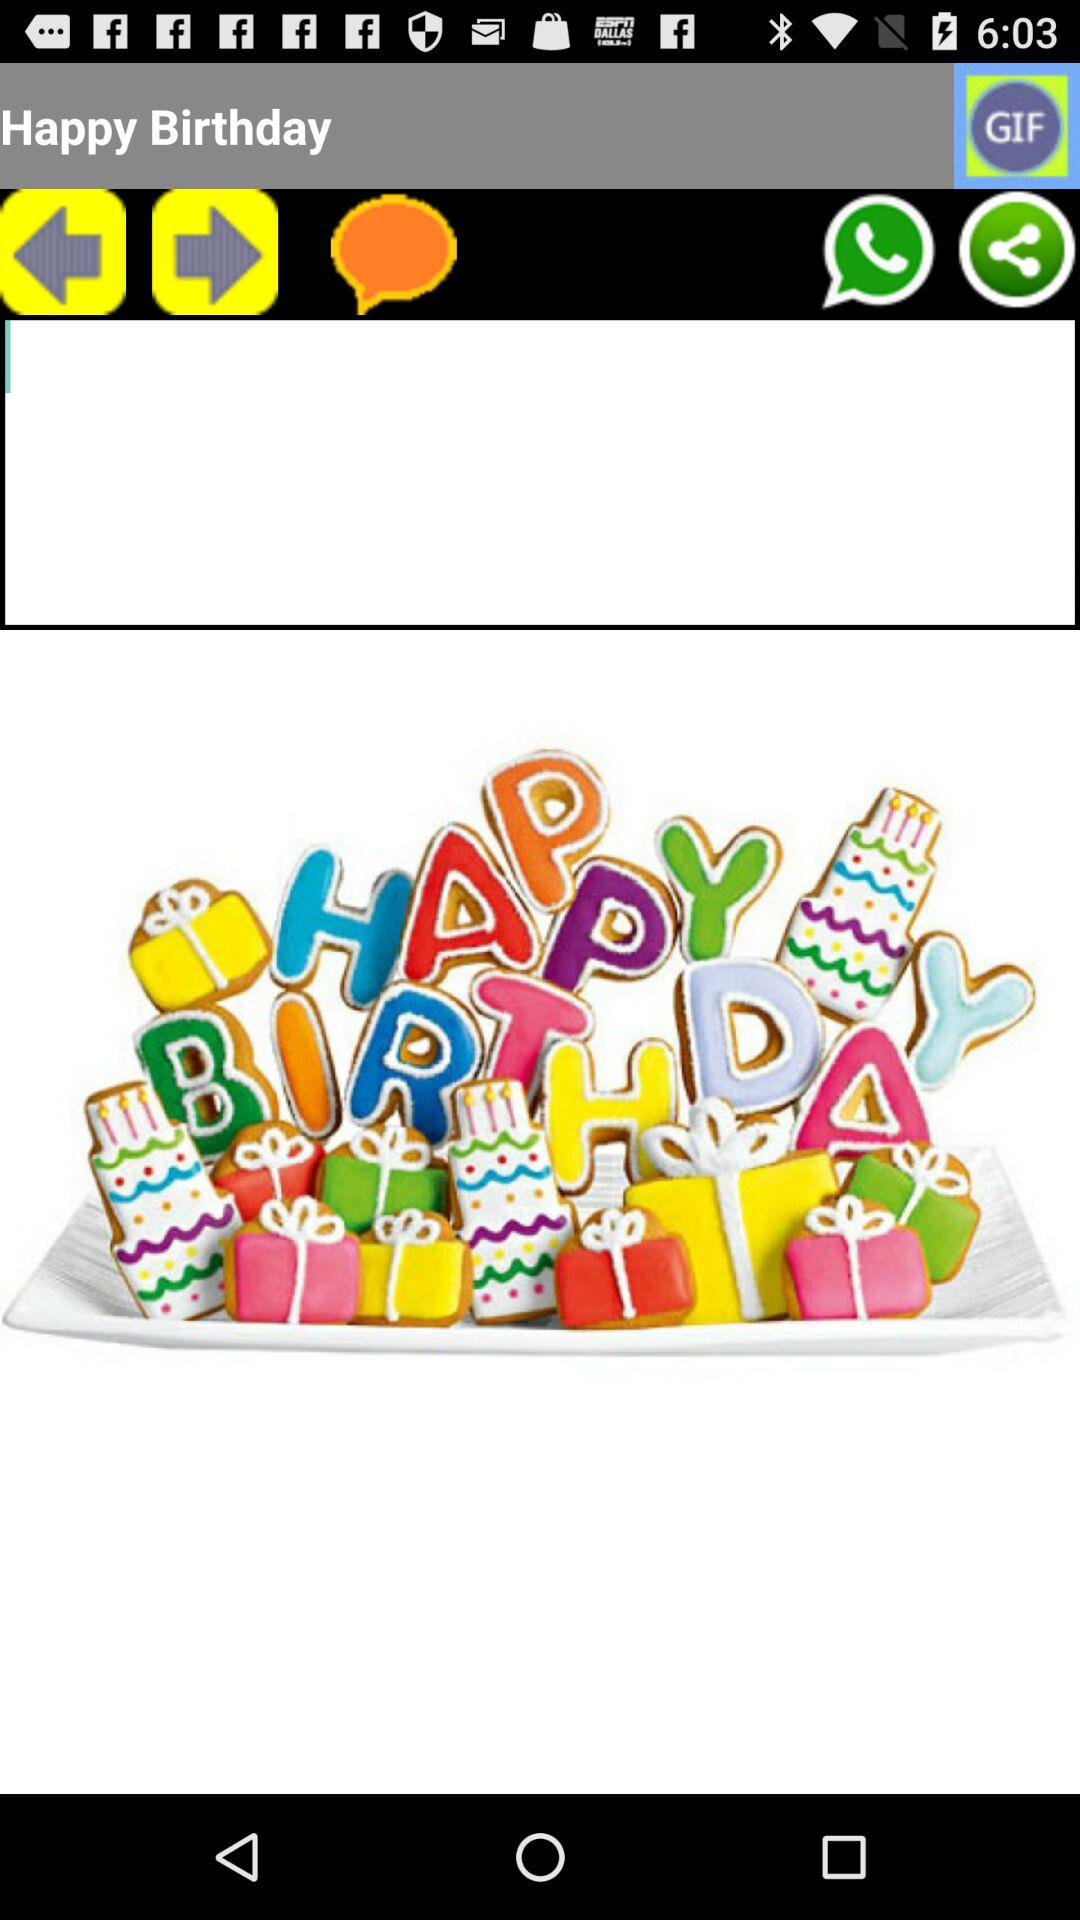What sharing options are given there? The given sharing option is "WhatsApp Messenger". 